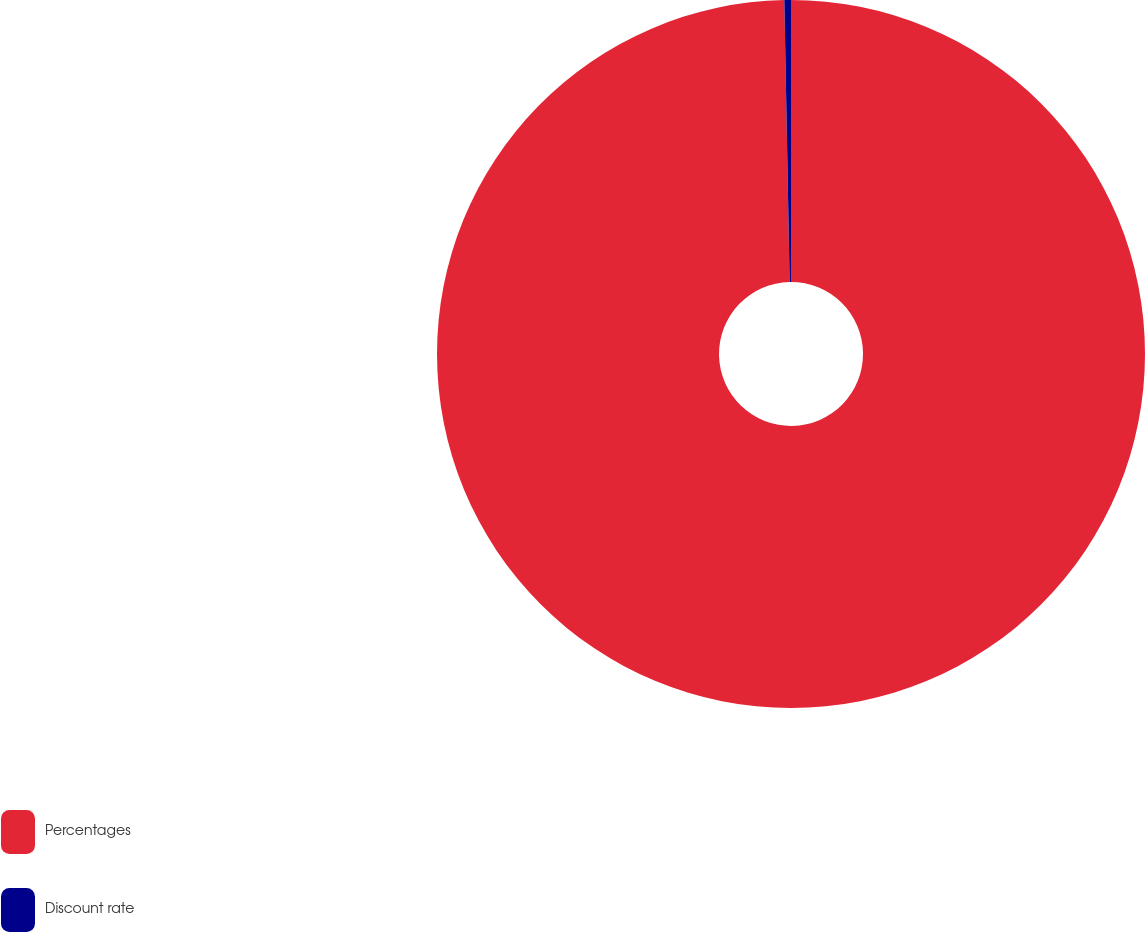Convert chart to OTSL. <chart><loc_0><loc_0><loc_500><loc_500><pie_chart><fcel>Percentages<fcel>Discount rate<nl><fcel>99.7%<fcel>0.3%<nl></chart> 